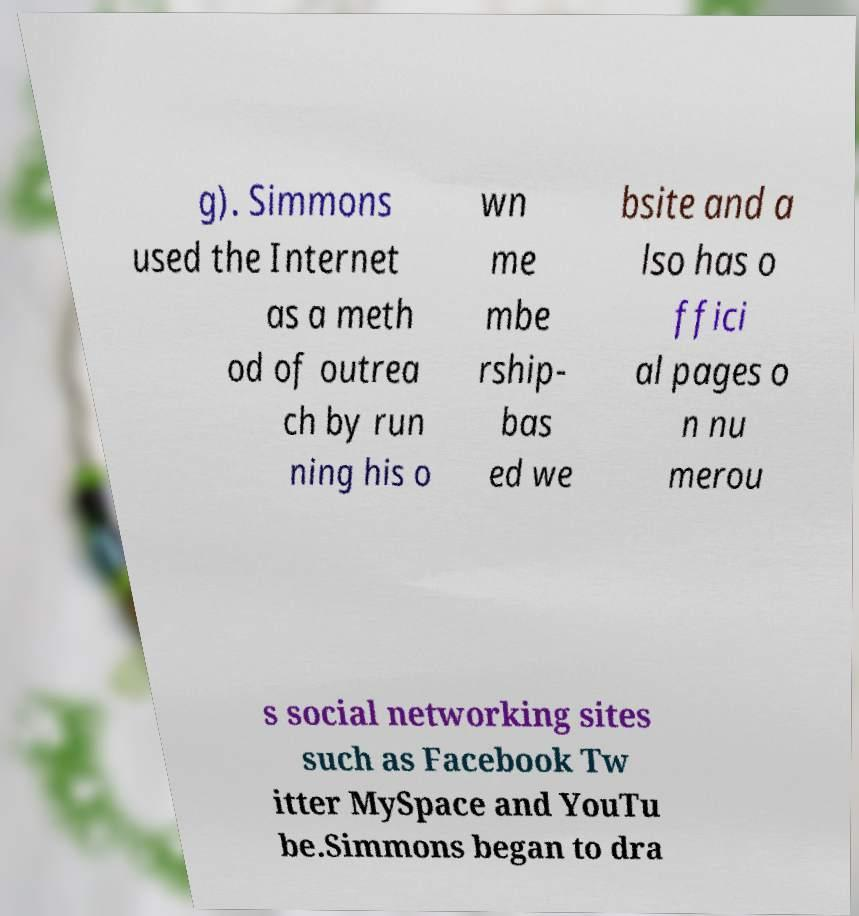Could you extract and type out the text from this image? g). Simmons used the Internet as a meth od of outrea ch by run ning his o wn me mbe rship- bas ed we bsite and a lso has o ffici al pages o n nu merou s social networking sites such as Facebook Tw itter MySpace and YouTu be.Simmons began to dra 